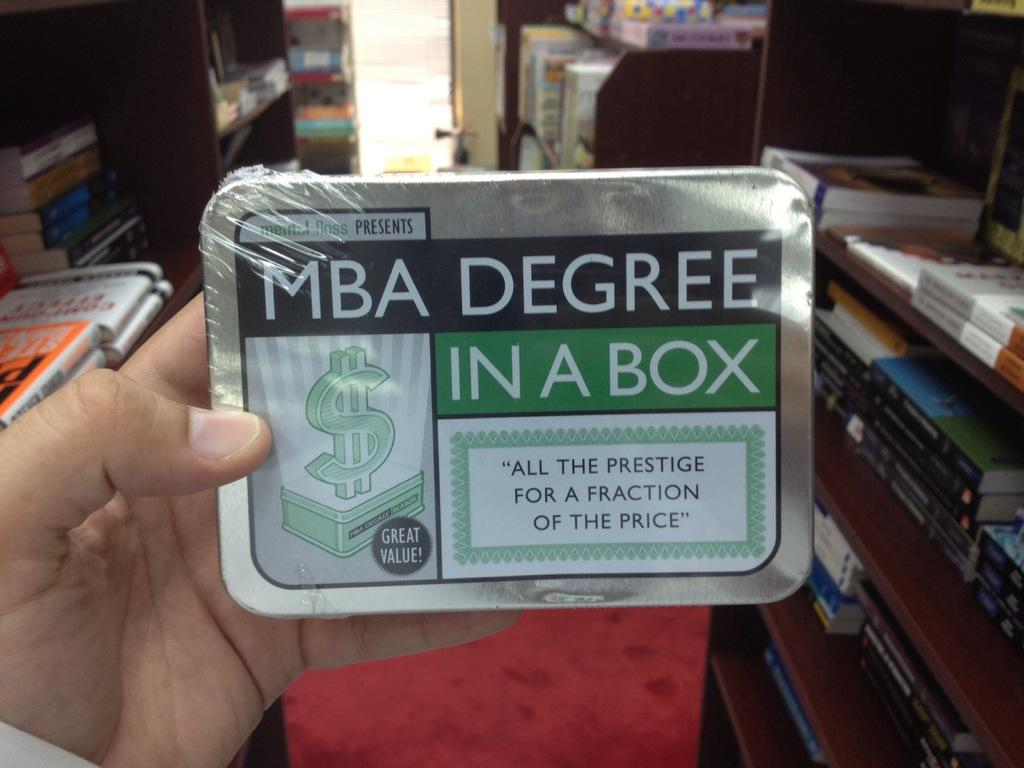<image>
Provide a brief description of the given image. A person is holding a tin box that says MBA Degree in a box. 